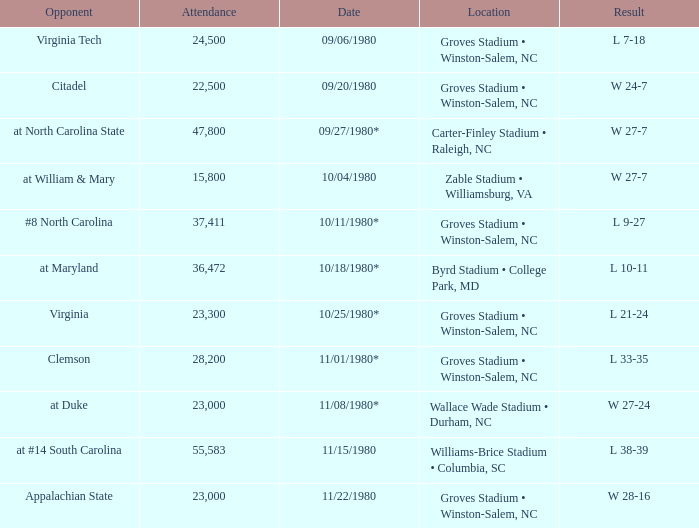How many people attended when Wake Forest played Virginia Tech? 24500.0. 